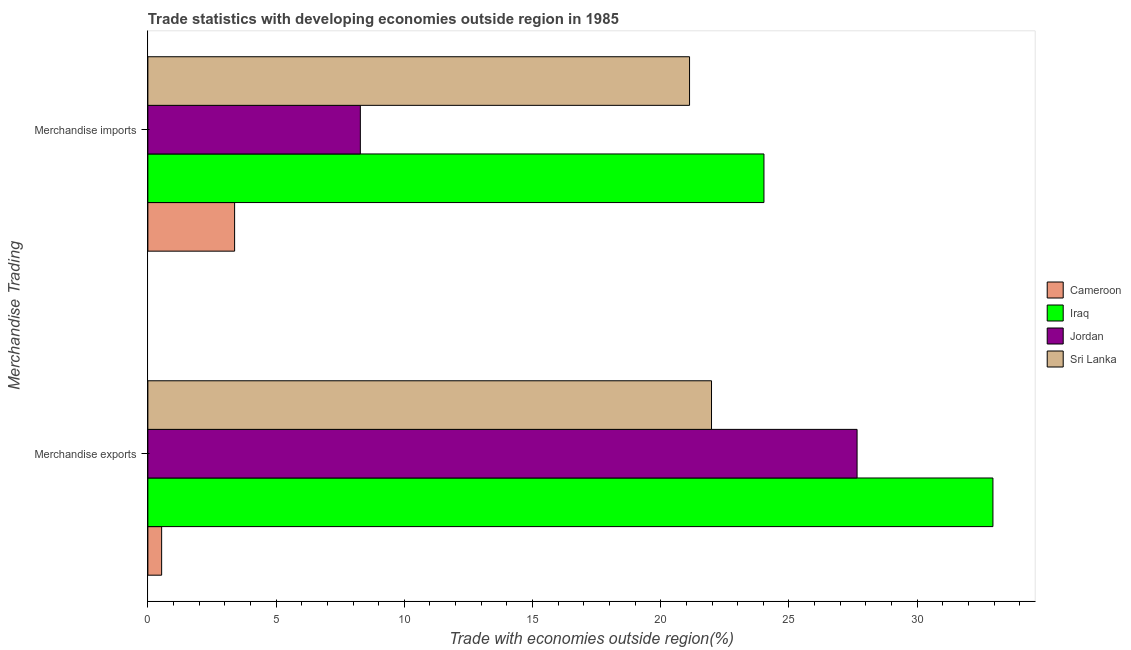How many different coloured bars are there?
Provide a succinct answer. 4. Are the number of bars per tick equal to the number of legend labels?
Give a very brief answer. Yes. How many bars are there on the 1st tick from the top?
Provide a succinct answer. 4. How many bars are there on the 2nd tick from the bottom?
Your response must be concise. 4. What is the merchandise imports in Sri Lanka?
Offer a very short reply. 21.12. Across all countries, what is the maximum merchandise exports?
Offer a terse response. 32.95. Across all countries, what is the minimum merchandise exports?
Ensure brevity in your answer.  0.54. In which country was the merchandise imports maximum?
Your answer should be very brief. Iraq. In which country was the merchandise imports minimum?
Give a very brief answer. Cameroon. What is the total merchandise imports in the graph?
Provide a short and direct response. 56.82. What is the difference between the merchandise imports in Jordan and that in Sri Lanka?
Your answer should be compact. -12.84. What is the difference between the merchandise imports in Sri Lanka and the merchandise exports in Jordan?
Your answer should be very brief. -6.53. What is the average merchandise imports per country?
Offer a very short reply. 14.2. What is the difference between the merchandise exports and merchandise imports in Jordan?
Provide a succinct answer. 19.37. In how many countries, is the merchandise exports greater than 13 %?
Keep it short and to the point. 3. What is the ratio of the merchandise imports in Sri Lanka to that in Iraq?
Your answer should be compact. 0.88. What does the 3rd bar from the top in Merchandise imports represents?
Offer a terse response. Iraq. What does the 1st bar from the bottom in Merchandise imports represents?
Ensure brevity in your answer.  Cameroon. Are all the bars in the graph horizontal?
Ensure brevity in your answer.  Yes. Are the values on the major ticks of X-axis written in scientific E-notation?
Keep it short and to the point. No. Where does the legend appear in the graph?
Your response must be concise. Center right. What is the title of the graph?
Provide a succinct answer. Trade statistics with developing economies outside region in 1985. What is the label or title of the X-axis?
Ensure brevity in your answer.  Trade with economies outside region(%). What is the label or title of the Y-axis?
Give a very brief answer. Merchandise Trading. What is the Trade with economies outside region(%) of Cameroon in Merchandise exports?
Provide a short and direct response. 0.54. What is the Trade with economies outside region(%) of Iraq in Merchandise exports?
Provide a succinct answer. 32.95. What is the Trade with economies outside region(%) in Jordan in Merchandise exports?
Your answer should be compact. 27.66. What is the Trade with economies outside region(%) of Sri Lanka in Merchandise exports?
Offer a very short reply. 21.98. What is the Trade with economies outside region(%) in Cameroon in Merchandise imports?
Your response must be concise. 3.38. What is the Trade with economies outside region(%) in Iraq in Merchandise imports?
Your answer should be very brief. 24.02. What is the Trade with economies outside region(%) of Jordan in Merchandise imports?
Your answer should be very brief. 8.29. What is the Trade with economies outside region(%) of Sri Lanka in Merchandise imports?
Keep it short and to the point. 21.12. Across all Merchandise Trading, what is the maximum Trade with economies outside region(%) in Cameroon?
Your answer should be very brief. 3.38. Across all Merchandise Trading, what is the maximum Trade with economies outside region(%) in Iraq?
Your answer should be very brief. 32.95. Across all Merchandise Trading, what is the maximum Trade with economies outside region(%) of Jordan?
Provide a succinct answer. 27.66. Across all Merchandise Trading, what is the maximum Trade with economies outside region(%) in Sri Lanka?
Give a very brief answer. 21.98. Across all Merchandise Trading, what is the minimum Trade with economies outside region(%) of Cameroon?
Keep it short and to the point. 0.54. Across all Merchandise Trading, what is the minimum Trade with economies outside region(%) of Iraq?
Your answer should be very brief. 24.02. Across all Merchandise Trading, what is the minimum Trade with economies outside region(%) of Jordan?
Offer a very short reply. 8.29. Across all Merchandise Trading, what is the minimum Trade with economies outside region(%) in Sri Lanka?
Provide a succinct answer. 21.12. What is the total Trade with economies outside region(%) of Cameroon in the graph?
Provide a succinct answer. 3.92. What is the total Trade with economies outside region(%) of Iraq in the graph?
Provide a short and direct response. 56.98. What is the total Trade with economies outside region(%) in Jordan in the graph?
Offer a terse response. 35.94. What is the total Trade with economies outside region(%) in Sri Lanka in the graph?
Offer a very short reply. 43.1. What is the difference between the Trade with economies outside region(%) of Cameroon in Merchandise exports and that in Merchandise imports?
Provide a succinct answer. -2.85. What is the difference between the Trade with economies outside region(%) of Iraq in Merchandise exports and that in Merchandise imports?
Give a very brief answer. 8.93. What is the difference between the Trade with economies outside region(%) of Jordan in Merchandise exports and that in Merchandise imports?
Your answer should be compact. 19.37. What is the difference between the Trade with economies outside region(%) of Sri Lanka in Merchandise exports and that in Merchandise imports?
Provide a short and direct response. 0.86. What is the difference between the Trade with economies outside region(%) in Cameroon in Merchandise exports and the Trade with economies outside region(%) in Iraq in Merchandise imports?
Provide a succinct answer. -23.49. What is the difference between the Trade with economies outside region(%) in Cameroon in Merchandise exports and the Trade with economies outside region(%) in Jordan in Merchandise imports?
Your response must be concise. -7.75. What is the difference between the Trade with economies outside region(%) in Cameroon in Merchandise exports and the Trade with economies outside region(%) in Sri Lanka in Merchandise imports?
Your response must be concise. -20.59. What is the difference between the Trade with economies outside region(%) in Iraq in Merchandise exports and the Trade with economies outside region(%) in Jordan in Merchandise imports?
Provide a short and direct response. 24.67. What is the difference between the Trade with economies outside region(%) in Iraq in Merchandise exports and the Trade with economies outside region(%) in Sri Lanka in Merchandise imports?
Your response must be concise. 11.83. What is the difference between the Trade with economies outside region(%) in Jordan in Merchandise exports and the Trade with economies outside region(%) in Sri Lanka in Merchandise imports?
Provide a succinct answer. 6.53. What is the average Trade with economies outside region(%) in Cameroon per Merchandise Trading?
Provide a succinct answer. 1.96. What is the average Trade with economies outside region(%) in Iraq per Merchandise Trading?
Your response must be concise. 28.49. What is the average Trade with economies outside region(%) in Jordan per Merchandise Trading?
Provide a succinct answer. 17.97. What is the average Trade with economies outside region(%) of Sri Lanka per Merchandise Trading?
Ensure brevity in your answer.  21.55. What is the difference between the Trade with economies outside region(%) in Cameroon and Trade with economies outside region(%) in Iraq in Merchandise exports?
Offer a terse response. -32.42. What is the difference between the Trade with economies outside region(%) in Cameroon and Trade with economies outside region(%) in Jordan in Merchandise exports?
Keep it short and to the point. -27.12. What is the difference between the Trade with economies outside region(%) in Cameroon and Trade with economies outside region(%) in Sri Lanka in Merchandise exports?
Provide a short and direct response. -21.44. What is the difference between the Trade with economies outside region(%) of Iraq and Trade with economies outside region(%) of Jordan in Merchandise exports?
Offer a very short reply. 5.3. What is the difference between the Trade with economies outside region(%) in Iraq and Trade with economies outside region(%) in Sri Lanka in Merchandise exports?
Provide a short and direct response. 10.97. What is the difference between the Trade with economies outside region(%) of Jordan and Trade with economies outside region(%) of Sri Lanka in Merchandise exports?
Make the answer very short. 5.68. What is the difference between the Trade with economies outside region(%) of Cameroon and Trade with economies outside region(%) of Iraq in Merchandise imports?
Your answer should be compact. -20.64. What is the difference between the Trade with economies outside region(%) of Cameroon and Trade with economies outside region(%) of Jordan in Merchandise imports?
Offer a very short reply. -4.9. What is the difference between the Trade with economies outside region(%) in Cameroon and Trade with economies outside region(%) in Sri Lanka in Merchandise imports?
Ensure brevity in your answer.  -17.74. What is the difference between the Trade with economies outside region(%) in Iraq and Trade with economies outside region(%) in Jordan in Merchandise imports?
Your answer should be very brief. 15.74. What is the difference between the Trade with economies outside region(%) of Iraq and Trade with economies outside region(%) of Sri Lanka in Merchandise imports?
Your answer should be very brief. 2.9. What is the difference between the Trade with economies outside region(%) in Jordan and Trade with economies outside region(%) in Sri Lanka in Merchandise imports?
Keep it short and to the point. -12.84. What is the ratio of the Trade with economies outside region(%) of Cameroon in Merchandise exports to that in Merchandise imports?
Your answer should be very brief. 0.16. What is the ratio of the Trade with economies outside region(%) in Iraq in Merchandise exports to that in Merchandise imports?
Your answer should be compact. 1.37. What is the ratio of the Trade with economies outside region(%) in Jordan in Merchandise exports to that in Merchandise imports?
Make the answer very short. 3.34. What is the ratio of the Trade with economies outside region(%) in Sri Lanka in Merchandise exports to that in Merchandise imports?
Provide a succinct answer. 1.04. What is the difference between the highest and the second highest Trade with economies outside region(%) of Cameroon?
Make the answer very short. 2.85. What is the difference between the highest and the second highest Trade with economies outside region(%) of Iraq?
Your answer should be very brief. 8.93. What is the difference between the highest and the second highest Trade with economies outside region(%) in Jordan?
Provide a short and direct response. 19.37. What is the difference between the highest and the second highest Trade with economies outside region(%) of Sri Lanka?
Offer a terse response. 0.86. What is the difference between the highest and the lowest Trade with economies outside region(%) of Cameroon?
Offer a very short reply. 2.85. What is the difference between the highest and the lowest Trade with economies outside region(%) in Iraq?
Keep it short and to the point. 8.93. What is the difference between the highest and the lowest Trade with economies outside region(%) of Jordan?
Provide a short and direct response. 19.37. What is the difference between the highest and the lowest Trade with economies outside region(%) in Sri Lanka?
Provide a short and direct response. 0.86. 